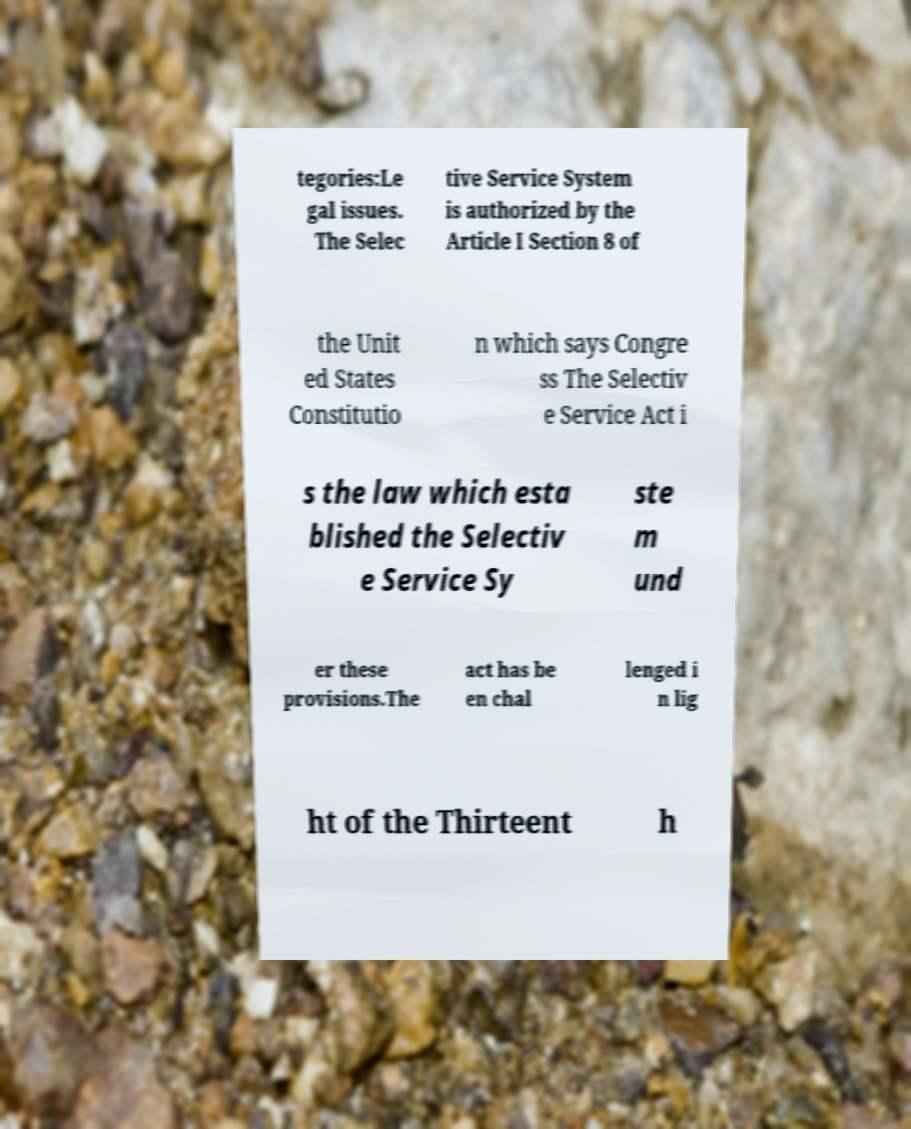Could you assist in decoding the text presented in this image and type it out clearly? tegories:Le gal issues. The Selec tive Service System is authorized by the Article I Section 8 of the Unit ed States Constitutio n which says Congre ss The Selectiv e Service Act i s the law which esta blished the Selectiv e Service Sy ste m und er these provisions.The act has be en chal lenged i n lig ht of the Thirteent h 